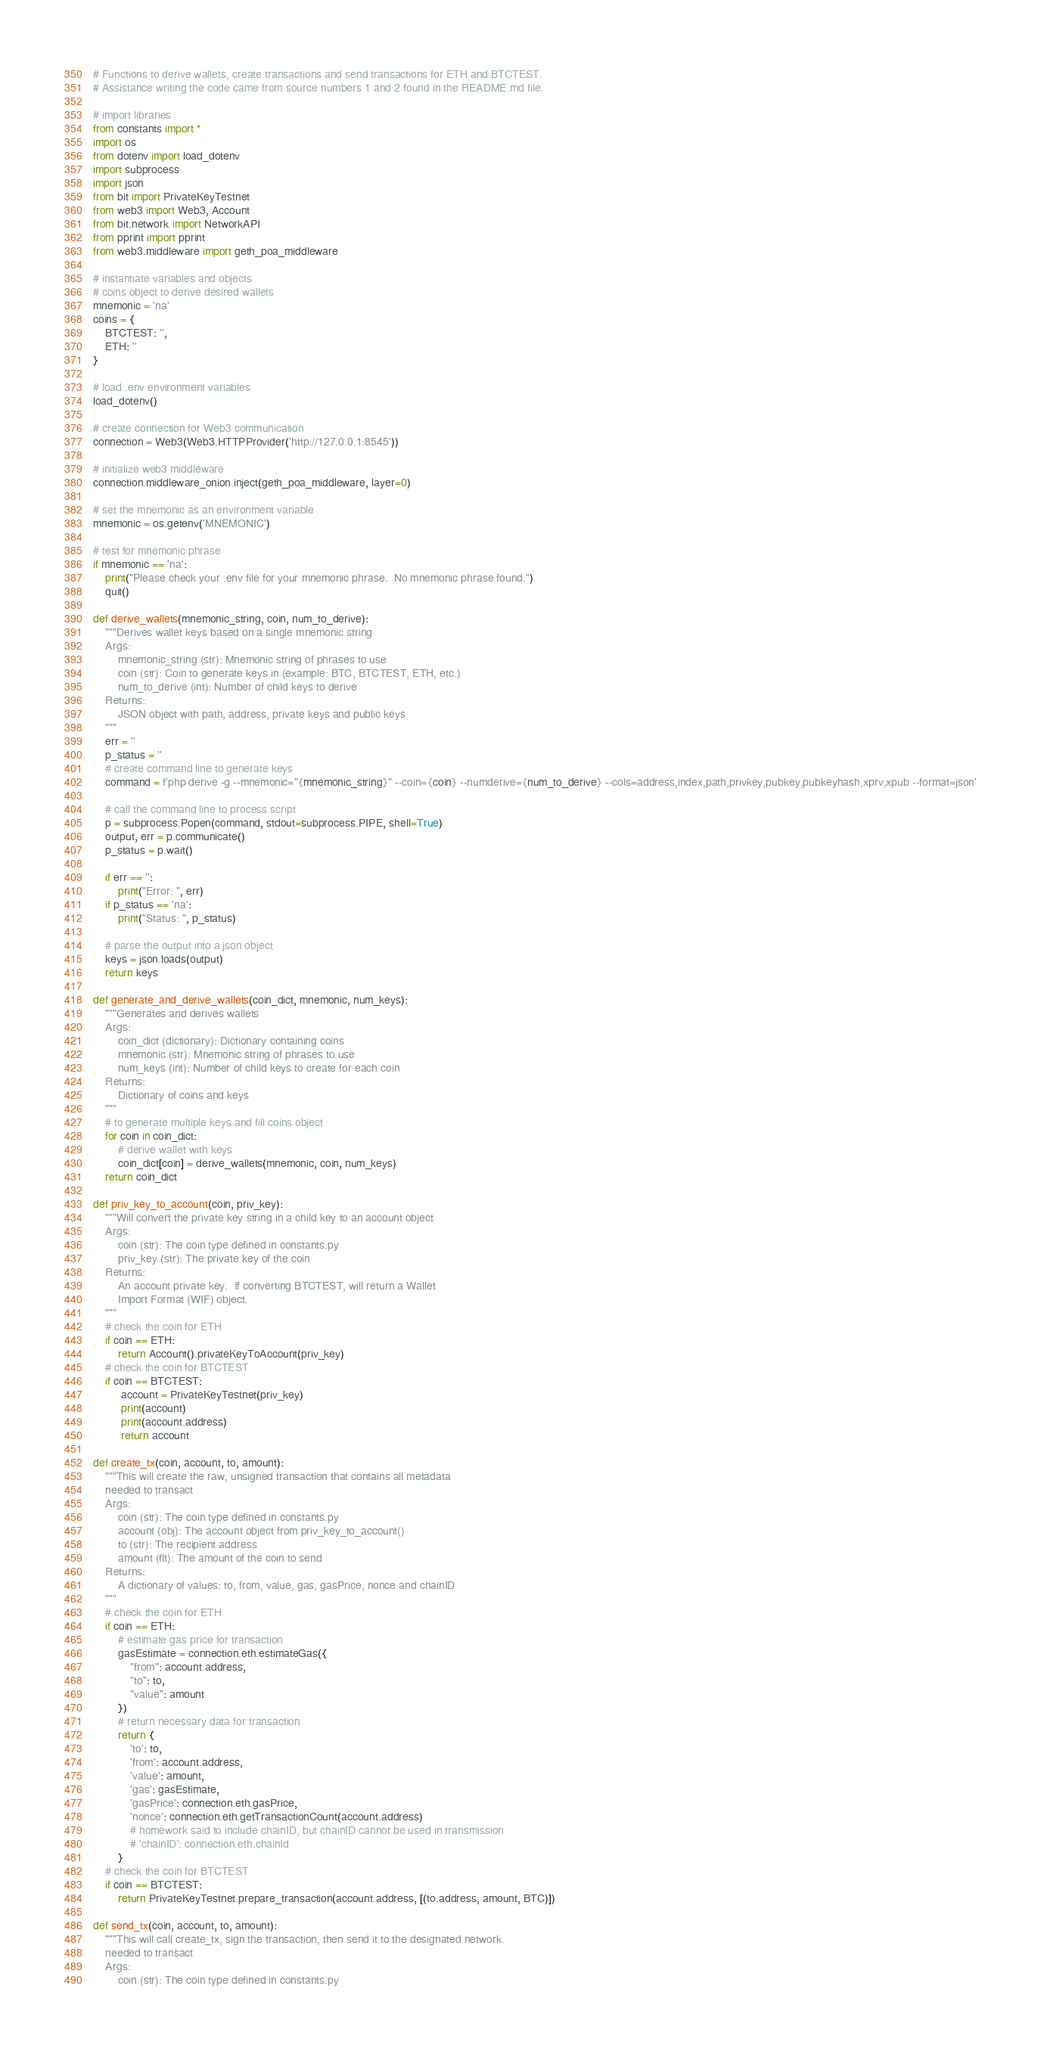<code> <loc_0><loc_0><loc_500><loc_500><_Python_># Functions to derive wallets, create transactions and send transactions for ETH and BTCTEST.
# Assistance writing the code came from source numbers 1 and 2 found in the README.md file.

# import libraries
from constants import *
import os
from dotenv import load_dotenv
import subprocess
import json
from bit import PrivateKeyTestnet
from web3 import Web3, Account
from bit.network import NetworkAPI
from pprint import pprint
from web3.middleware import geth_poa_middleware

# instantiate variables and objects
# coins object to derive desired wallets
mnemonic = 'na'
coins = {
    BTCTEST: '',
    ETH: ''
}

# load .env environment variables
load_dotenv()

# create connection for Web3 communication
connection = Web3(Web3.HTTPProvider('http://127.0.0.1:8545'))

# initialize web3 middleware
connection.middleware_onion.inject(geth_poa_middleware, layer=0)

# set the mnemonic as an environment variable
mnemonic = os.getenv('MNEMONIC')

# test for mnemonic phrase
if mnemonic == 'na':
    print("Please check your .env file for your mnemonic phrase.  No mnemonic phrase found.")
    quit()

def derive_wallets(mnemonic_string, coin, num_to_derive):
    """Derives wallet keys based on a single mnemonic string
    Args:
        mnemonic_string (str): Mnemonic string of phrases to use
        coin (str): Coin to generate keys in (example: BTC, BTCTEST, ETH, etc.)
        num_to_derive (int): Number of child keys to derive
    Returns:
        JSON object with path, address, private keys and public keys
    """
    err = ''
    p_status = ''
    # create command line to generate keys
    command = f'php derive -g --mnemonic="{mnemonic_string}" --coin={coin} --numderive={num_to_derive} --cols=address,index,path,privkey,pubkey,pubkeyhash,xprv,xpub --format=json'
    
    # call the command line to process script
    p = subprocess.Popen(command, stdout=subprocess.PIPE, shell=True)
    output, err = p.communicate()
    p_status = p.wait()

    if err == '':
        print("Error: ", err)
    if p_status == 'na':
        print("Status: ", p_status)

    # parse the output into a json object
    keys = json.loads(output)
    return keys

def generate_and_derive_wallets(coin_dict, mnemonic, num_keys):
    """Generates and derives wallets
    Args:
        coin_dict (dictionary): Dictionary containing coins
        mnemonic (str): Mnemonic string of phrases to use
        num_keys (int): Number of child keys to create for each coin
    Returns:
        Dictionary of coins and keys
    """
    # to generate multiple keys and fill coins object
    for coin in coin_dict:
        # derive wallet with keys
        coin_dict[coin] = derive_wallets(mnemonic, coin, num_keys)
    return coin_dict

def priv_key_to_account(coin, priv_key):
    """Will convert the private key string in a child key to an account object
    Args:
        coin (str): The coin type defined in constants.py
        priv_key (str): The private key of the coin
    Returns:
        An account private key.  If converting BTCTEST, will return a Wallet
        Import Format (WIF) object.
    """
    # check the coin for ETH
    if coin == ETH:
        return Account().privateKeyToAccount(priv_key)
    # check the coin for BTCTEST
    if coin == BTCTEST:
         account = PrivateKeyTestnet(priv_key)
         print(account)
         print(account.address)
         return account

def create_tx(coin, account, to, amount):
    """This will create the raw, unsigned transaction that contains all metadata 
    needed to transact
    Args:
        coin (str): The coin type defined in constants.py
        account (obj): The account object from priv_key_to_account()
        to (str): The recipient address
        amount (flt): The amount of the coin to send
    Returns:
        A dictionary of values: to, from, value, gas, gasPrice, nonce and chainID
    """
    # check the coin for ETH
    if coin == ETH:
        # estimate gas price for transaction
        gasEstimate = connection.eth.estimateGas({
            "from": account.address,
            "to": to,
            "value": amount
        })
        # return necessary data for transaction
        return {
            'to': to,
            'from': account.address,
            'value': amount,
            'gas': gasEstimate,
            'gasPrice': connection.eth.gasPrice,
            'nonce': connection.eth.getTransactionCount(account.address)
            # homework said to include chainID, but chainID cannot be used in transmission
            # 'chainID': connection.eth.chainId
        }
    # check the coin for BTCTEST
    if coin == BTCTEST:
        return PrivateKeyTestnet.prepare_transaction(account.address, [(to.address, amount, BTC)])

def send_tx(coin, account, to, amount):
    """This will call create_tx, sign the transaction, then send it to the designated network.
    needed to transact
    Args:
        coin (str): The coin type defined in constants.py</code> 